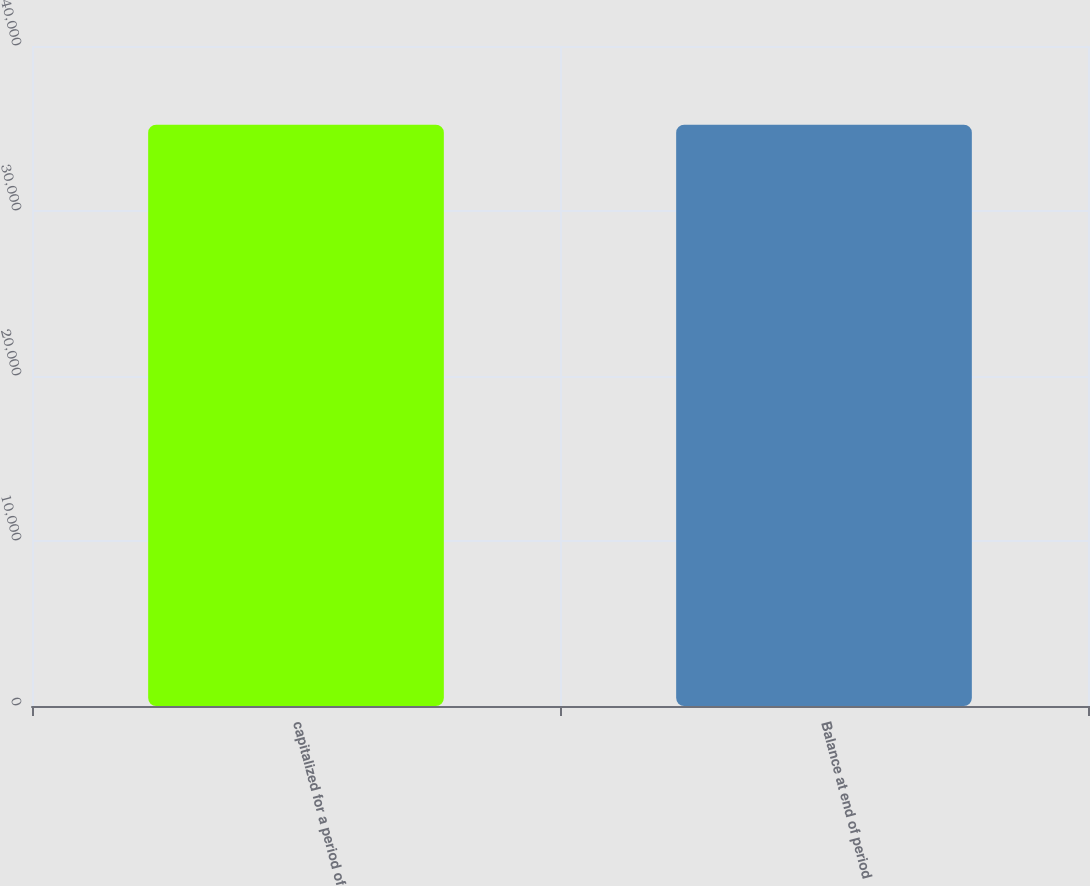Convert chart. <chart><loc_0><loc_0><loc_500><loc_500><bar_chart><fcel>capitalized for a period of<fcel>Balance at end of period<nl><fcel>35228<fcel>35228.1<nl></chart> 